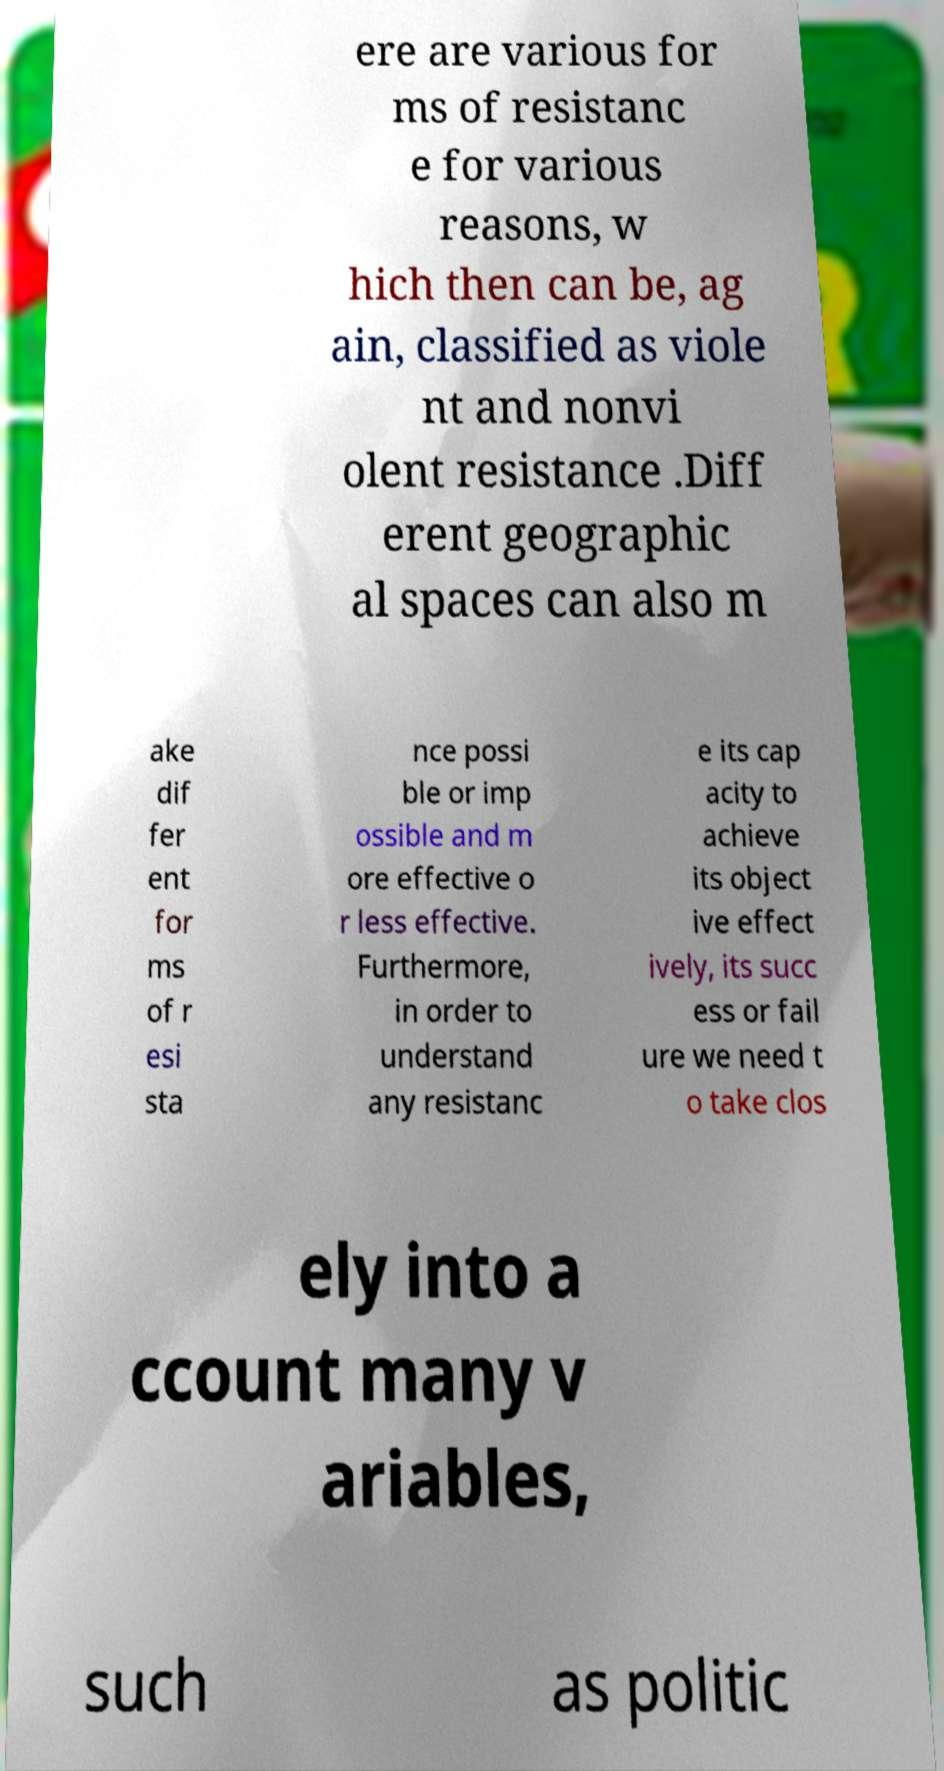Can you accurately transcribe the text from the provided image for me? ere are various for ms of resistanc e for various reasons, w hich then can be, ag ain, classified as viole nt and nonvi olent resistance .Diff erent geographic al spaces can also m ake dif fer ent for ms of r esi sta nce possi ble or imp ossible and m ore effective o r less effective. Furthermore, in order to understand any resistanc e its cap acity to achieve its object ive effect ively, its succ ess or fail ure we need t o take clos ely into a ccount many v ariables, such as politic 